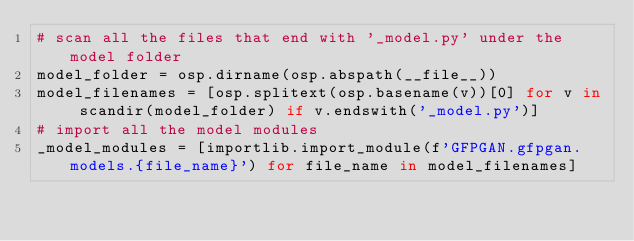Convert code to text. <code><loc_0><loc_0><loc_500><loc_500><_Python_># scan all the files that end with '_model.py' under the model folder
model_folder = osp.dirname(osp.abspath(__file__))
model_filenames = [osp.splitext(osp.basename(v))[0] for v in scandir(model_folder) if v.endswith('_model.py')]
# import all the model modules
_model_modules = [importlib.import_module(f'GFPGAN.gfpgan.models.{file_name}') for file_name in model_filenames]
</code> 